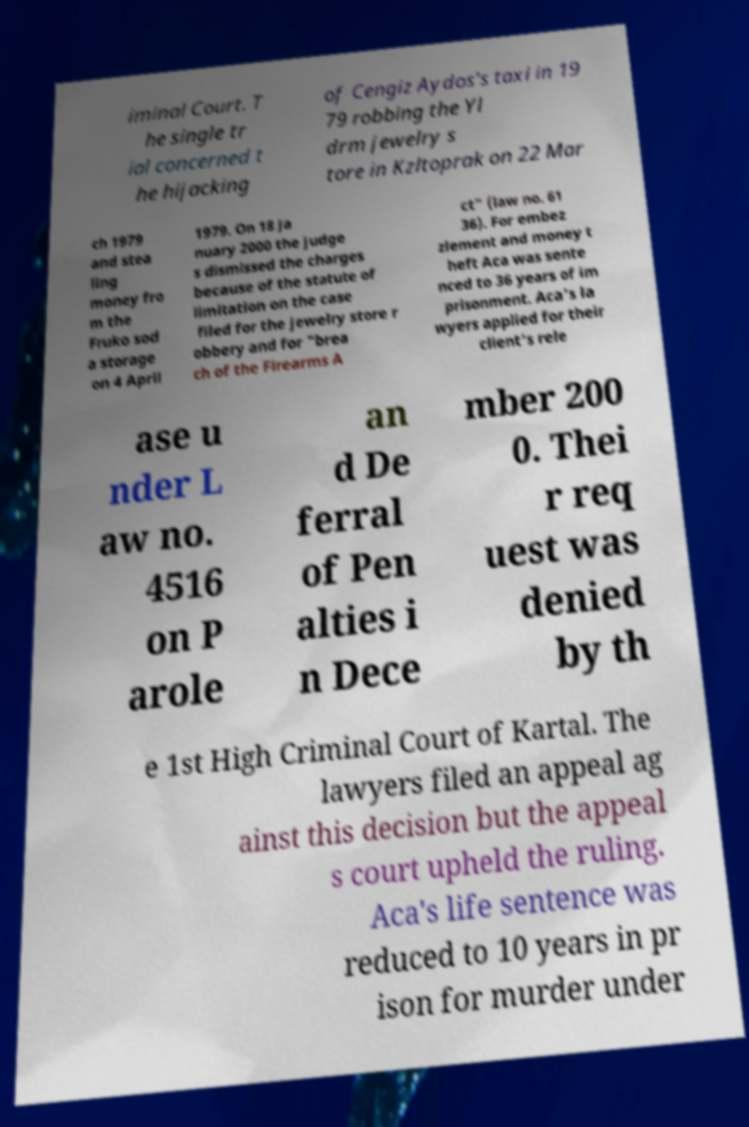For documentation purposes, I need the text within this image transcribed. Could you provide that? iminal Court. T he single tr ial concerned t he hijacking of Cengiz Aydos's taxi in 19 79 robbing the Yl drm jewelry s tore in Kzltoprak on 22 Mar ch 1979 and stea ling money fro m the Fruko sod a storage on 4 April 1979. On 18 Ja nuary 2000 the judge s dismissed the charges because of the statute of limitation on the case filed for the jewelry store r obbery and for "brea ch of the Firearms A ct" (law no. 61 36). For embez zlement and money t heft Aca was sente nced to 36 years of im prisonment. Aca's la wyers applied for their client's rele ase u nder L aw no. 4516 on P arole an d De ferral of Pen alties i n Dece mber 200 0. Thei r req uest was denied by th e 1st High Criminal Court of Kartal. The lawyers filed an appeal ag ainst this decision but the appeal s court upheld the ruling. Aca's life sentence was reduced to 10 years in pr ison for murder under 